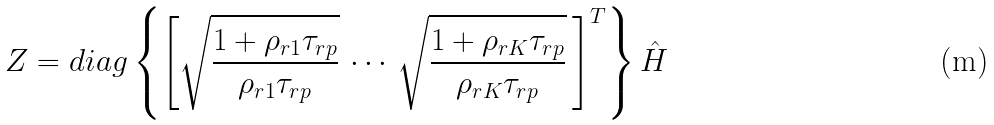<formula> <loc_0><loc_0><loc_500><loc_500>Z = d i a g \left \{ \left [ \sqrt { \frac { 1 + \rho _ { r 1 } \tau _ { r p } } { \rho _ { r 1 } \tau _ { r p } } } \, \cdots \, \sqrt { \frac { 1 + \rho _ { r K } \tau _ { r p } } { \rho _ { r K } \tau _ { r p } } } \, \right ] ^ { T } \right \} \hat { H }</formula> 